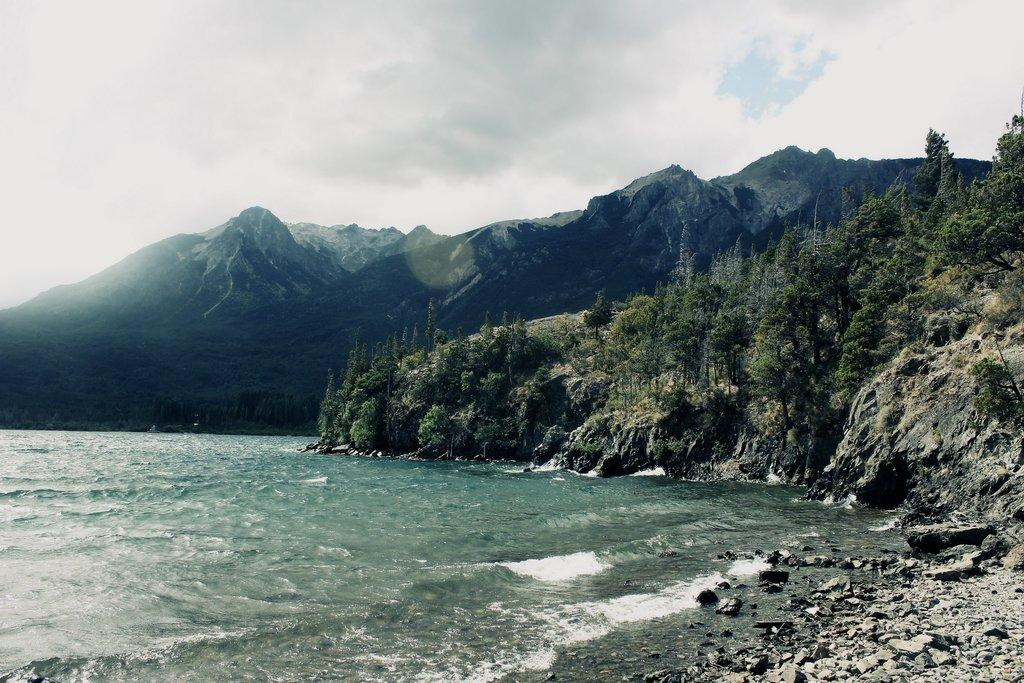What is one of the natural elements present in the image? There is water in the image. What type of vegetation can be seen in the image? There are trees in the image. What geographical features are visible in the image? There are hills in the image. What type of terrain is present in the image? There are rocks in the image. What is visible in the background of the image? The sky is visible in the image. What atmospheric conditions can be observed in the sky? Clouds are present in the sky. How many pigs are seen playing with the rocks in the image? There are no pigs present in the image; it features water, trees, hills, rocks, and a sky with clouds. 